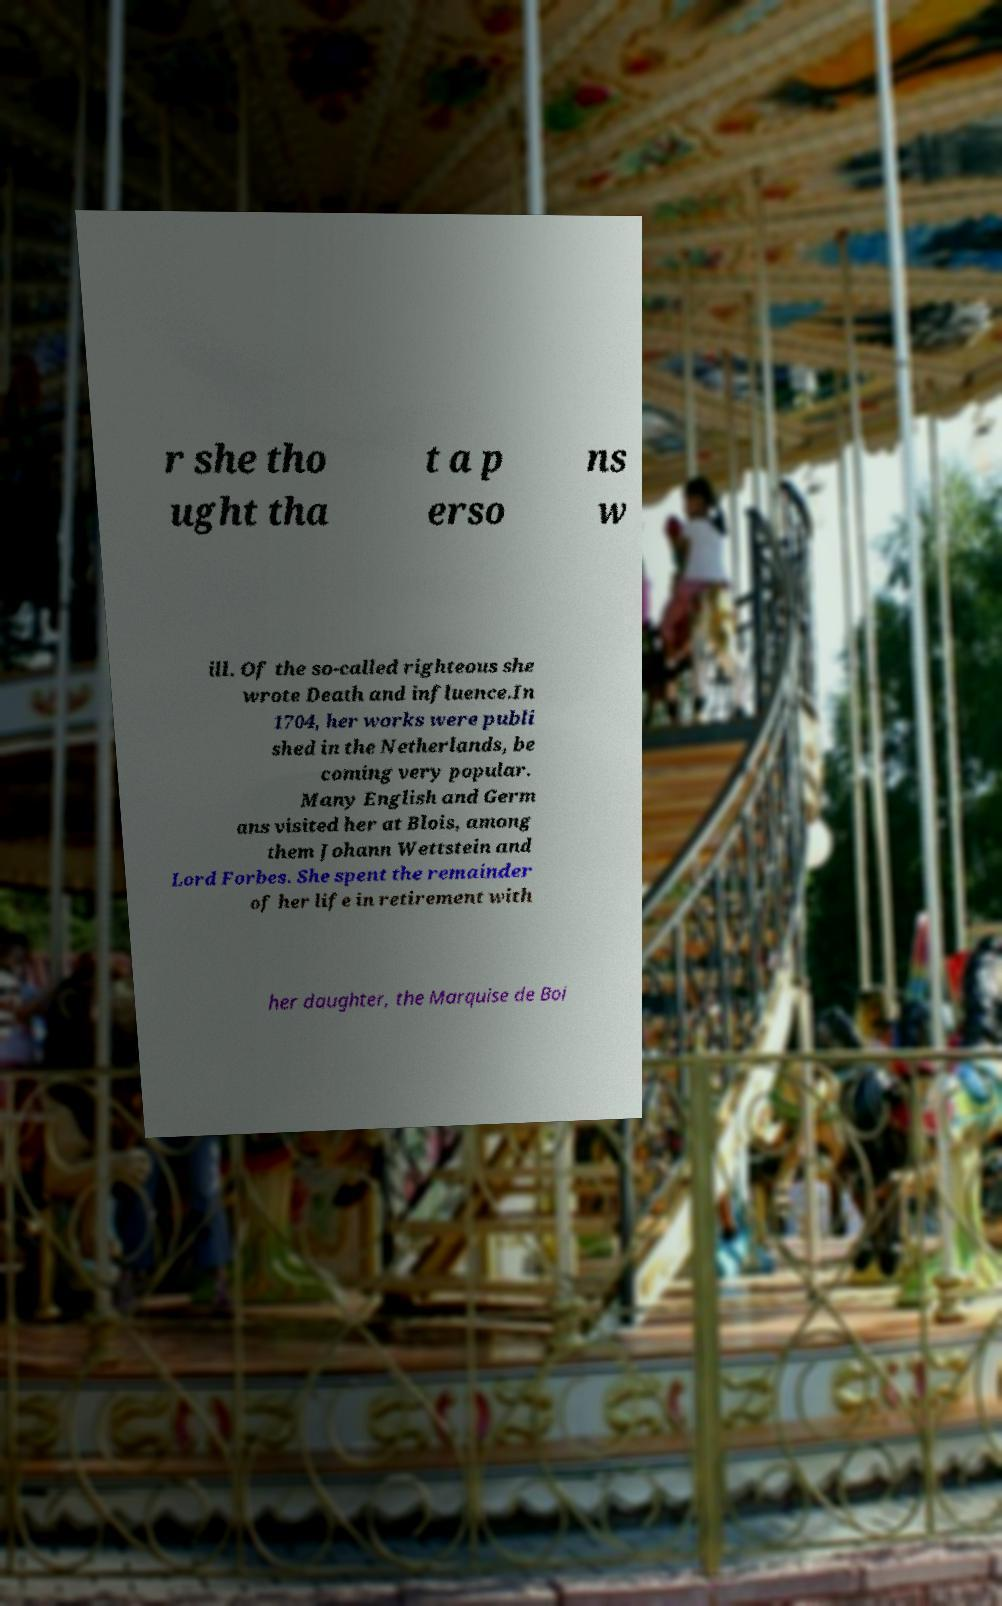Can you accurately transcribe the text from the provided image for me? r she tho ught tha t a p erso ns w ill. Of the so-called righteous she wrote Death and influence.In 1704, her works were publi shed in the Netherlands, be coming very popular. Many English and Germ ans visited her at Blois, among them Johann Wettstein and Lord Forbes. She spent the remainder of her life in retirement with her daughter, the Marquise de Boi 